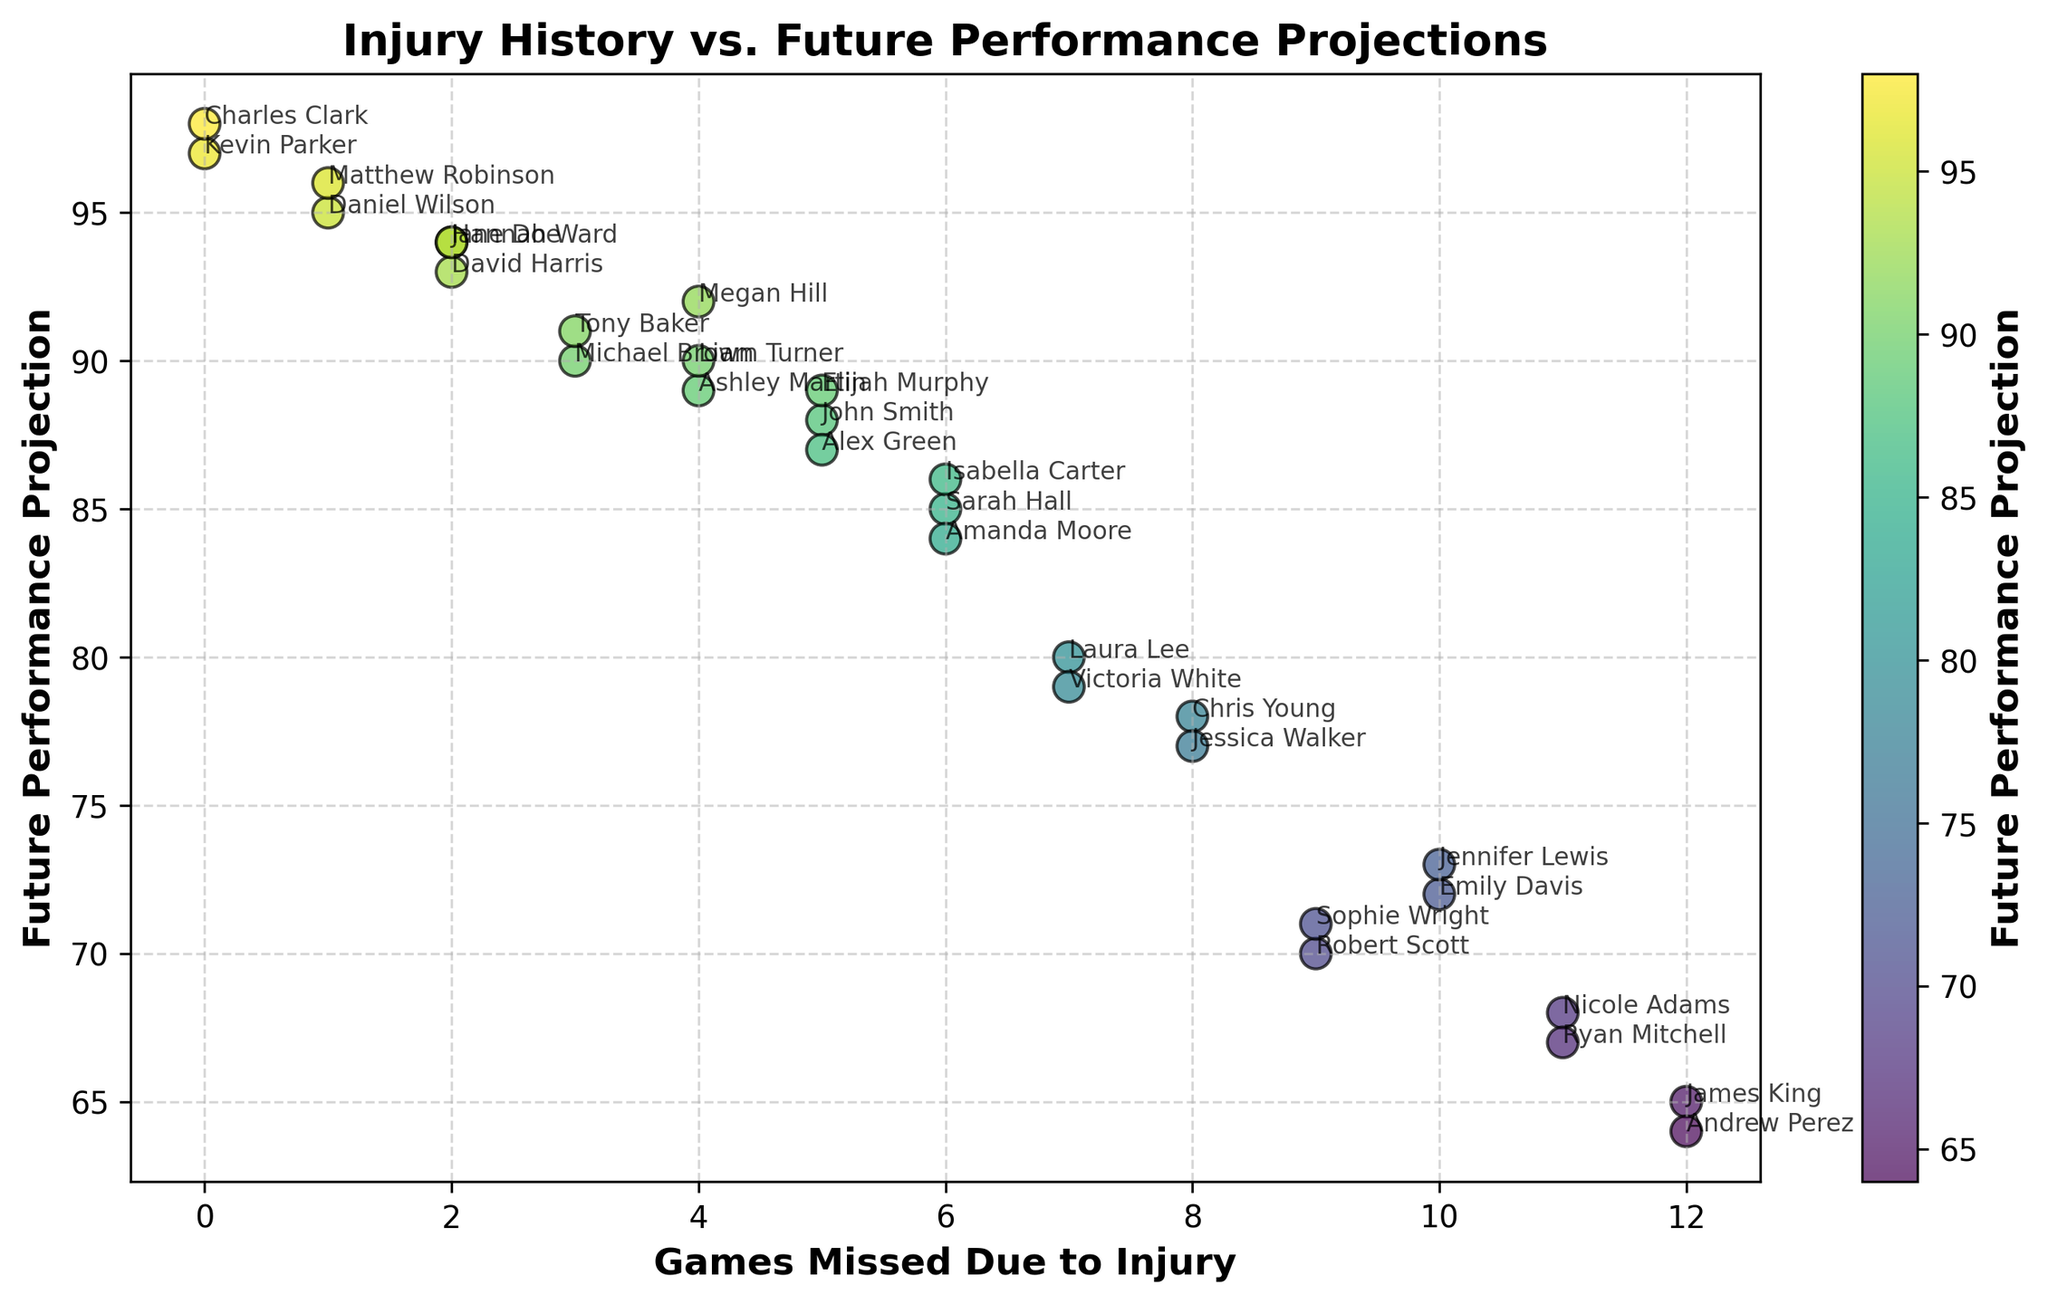Which player has the highest future performance projection? Scan the y-axis values and locate the player with the highest future performance projection, which is 98.
Answer: Charles Clark Which player has the lowest future performance projection? Scan the y-axis values and locate the player with the lowest future performance projection, which is 64.
Answer: Andrew Perez What is the average future performance projection for players who missed 5 games due to injury? Identify players who missed 5 games (John Smith, Alex Green, Elijah Murphy). Sum their future performance projections (88 + 87 + 89 = 264). Divide the sum by the number of players (264/3 = 88).
Answer: 88 Which player missed the fewest games and what is their future performance projection? Find the player with 0 games missed (Kevin Parker, Charles Clark). Check their future performance projections (97, 98). Both players have projections, but Charles Clark's future performance projection is slightly higher.
Answer: Charles Clark, 98 How many players have a future performance projection greater than 90? Count the players with future performance projections over 90 (Jane Doe, Michael Brown, Daniel Wilson, Megan Hill, Tony Baker, Matthew Robinson, Kevin Parker, Charles Clark).
Answer: 8 Is there a correlation between games missed due to injury and future performance projections? If so, is it positive or negative? Observe the trend of data points. Generally, as games missed increase, the future performance projection decreases. This indicates a negative correlation.
Answer: Negative What is the combined future performance projection of all players who missed more than 10 games? Identify players who missed more than 10 games (James King, Nicole Adams, Ryan Mitchell, Andrew Perez). Sum their future performance projections (65 + 68 + 67 + 64 = 264).
Answer: 264 Who has a better future performance projection: player with 7 games missed or player with 8 games missed? Compare future performance projections of players who missed 7 games (Laura Lee, Victoria White), and players who missed 8 games (Chris Young, Jessica Walker). Highest for 7 games: Laura Lee - 80, Victoria White - 79. Highest for 8 games: Chris Young - 78, Jessica Walker - 77. 80 > 78, so better projection with 7 games missed.
Answer: Laura Lee What is the median future performance projection for all players listed? Arrange all future performance projections in ascending order. Find the middle value(s). For 30 projections, the median is the average of the 15th and 16th values (86 and 87, respectively), which is (86+87)/2 = 86.5.
Answer: 86.5 Compare the future performance projections of players who missed 4 games with those who missed 6 games. Which group performs better on average? Identify players who missed 4 games (Megan Hill, Ashley Martin, Liam Turner). Sum their projections and find the average (92 + 89 + 90 = 271, 271/3 ≈ 90.33). Identify players who missed 6 games (Sarah Hall, Amanda Moore, Isabella Carter). Sum and find the average (85 + 84 + 86 = 255, 255/3 = 85). 90.33 > 85, so players who missed 4 games perform better on average.
Answer: 4 games Which player has the future performance projection closest to the average for all players? First, calculate the average future performance projection. Sum all projections (John Smith: 88, Jane Doe: 94, ... Hannah Ward: 94) and divide by 30, resulting in an average close to 83. Identify the player with the closest value to 83, which is Sarah Hall with 85.
Answer: Sarah Hall 